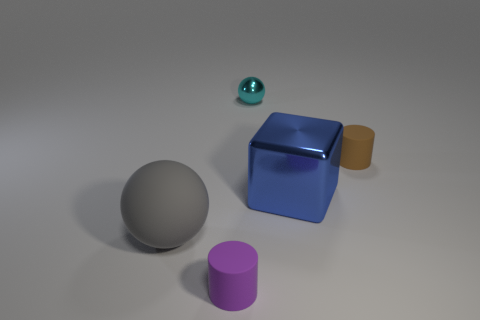Add 2 tiny purple matte cylinders. How many objects exist? 7 Subtract all spheres. How many objects are left? 3 Add 1 tiny purple cubes. How many tiny purple cubes exist? 1 Subtract 1 blue blocks. How many objects are left? 4 Subtract all big gray spheres. Subtract all cylinders. How many objects are left? 2 Add 4 cyan spheres. How many cyan spheres are left? 5 